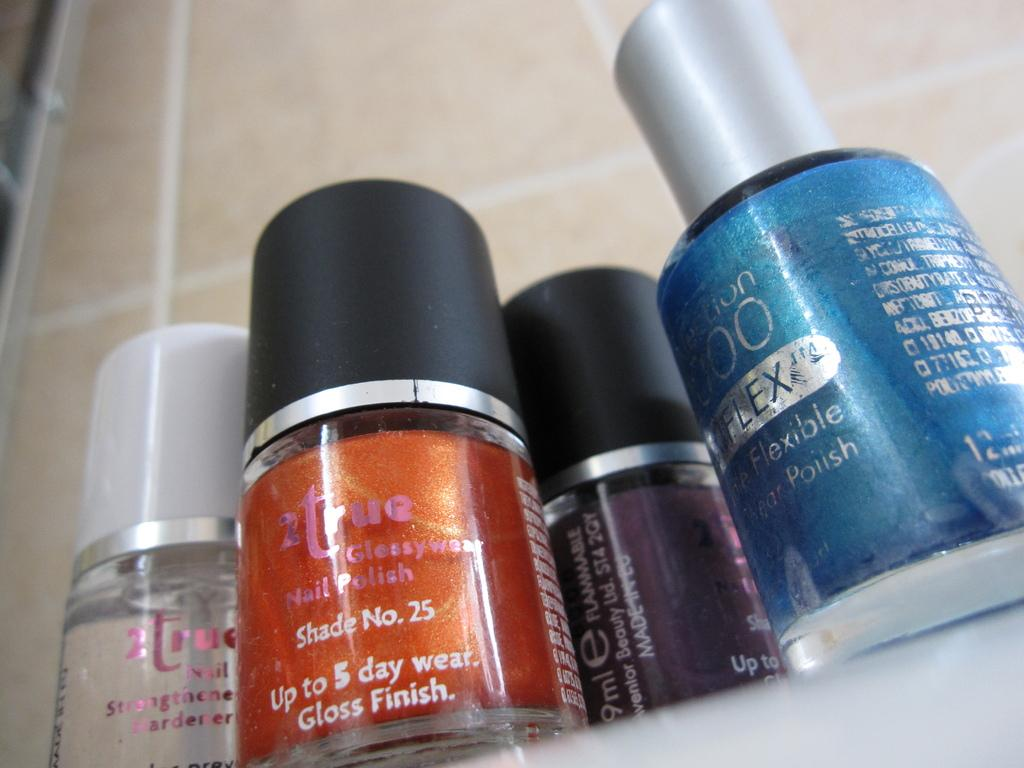<image>
Present a compact description of the photo's key features. A reddish nail polish in shade number 25 is on a shelf with other colors. 